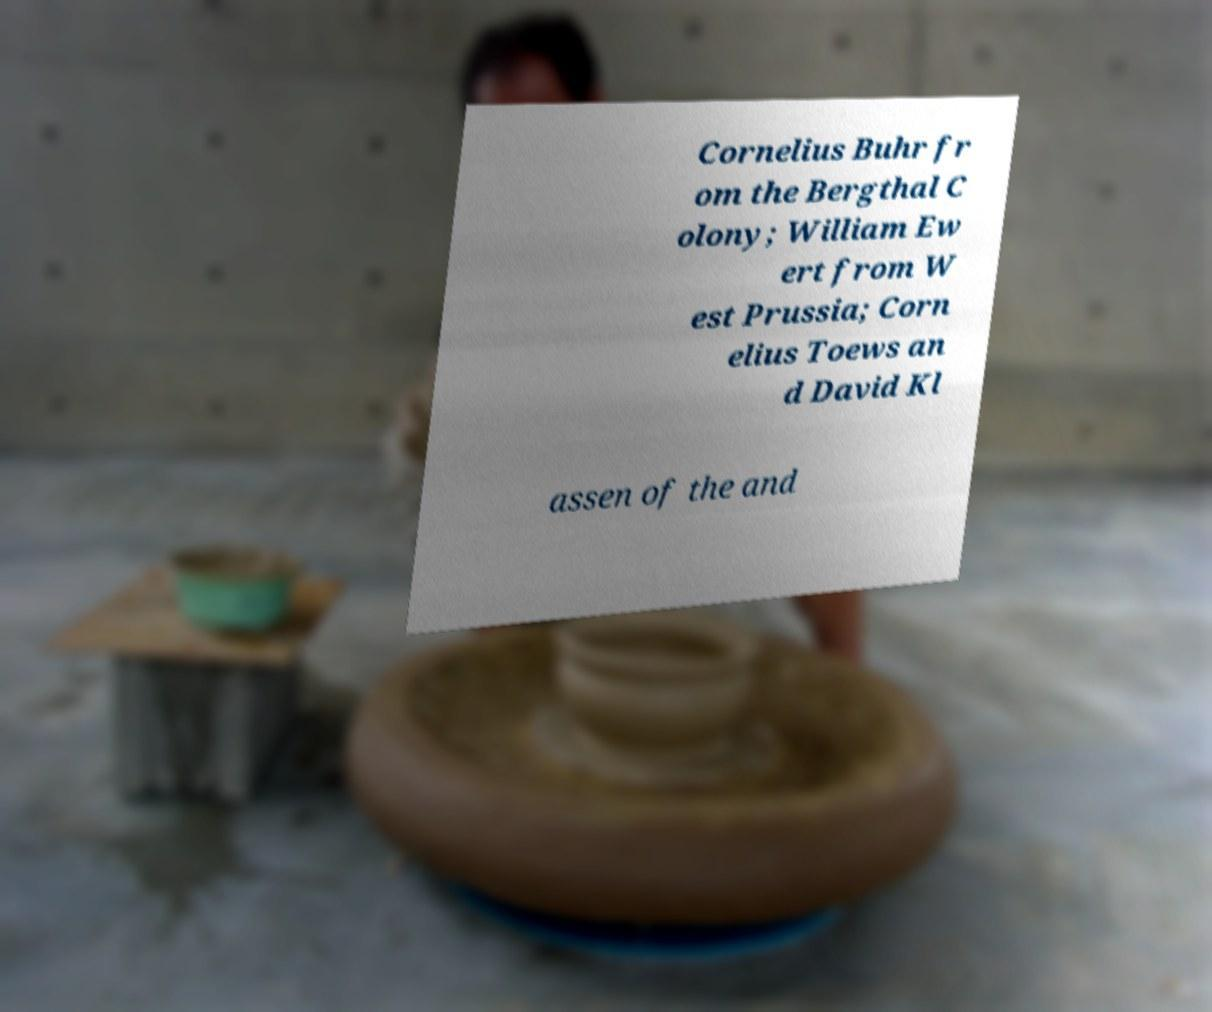Could you extract and type out the text from this image? Cornelius Buhr fr om the Bergthal C olony; William Ew ert from W est Prussia; Corn elius Toews an d David Kl assen of the and 